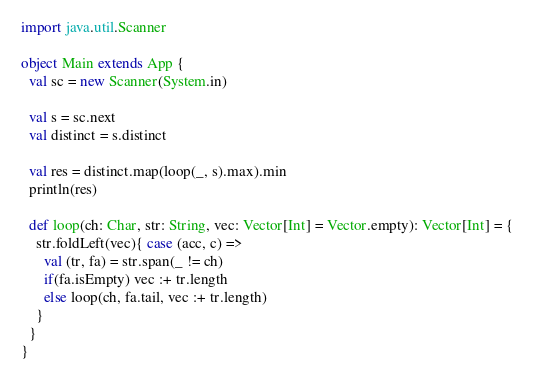Convert code to text. <code><loc_0><loc_0><loc_500><loc_500><_Scala_>import java.util.Scanner

object Main extends App {
  val sc = new Scanner(System.in)

  val s = sc.next
  val distinct = s.distinct

  val res = distinct.map(loop(_, s).max).min
  println(res)

  def loop(ch: Char, str: String, vec: Vector[Int] = Vector.empty): Vector[Int] = {
    str.foldLeft(vec){ case (acc, c) =>
      val (tr, fa) = str.span(_ != ch)
      if(fa.isEmpty) vec :+ tr.length
      else loop(ch, fa.tail, vec :+ tr.length)
    }
  }
}</code> 